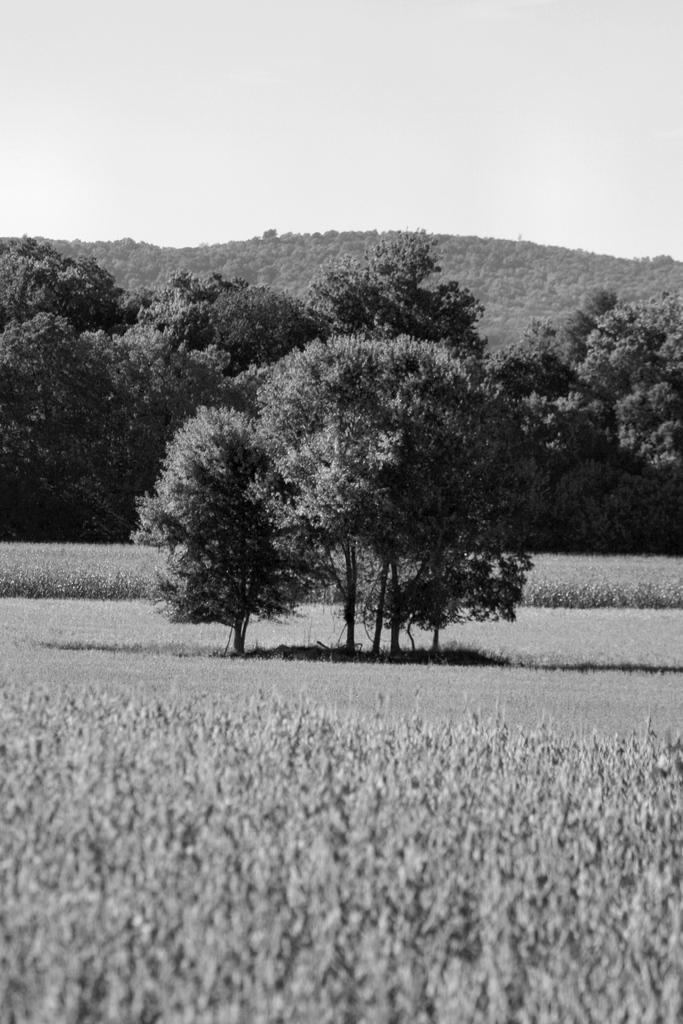What is the color scheme of the image? The image is black and white. What type of vegetation can be seen in the image? There are trees and plants in the image. What is visible in the background of the image? The sky is visible in the background of the image. How many friends can be seen in the image? There are no people or friends present in the image; it features trees, plants, and a sky. What type of tail is visible on the tree in the image? There is no tail present in the image; it features trees, plants, and a sky. 